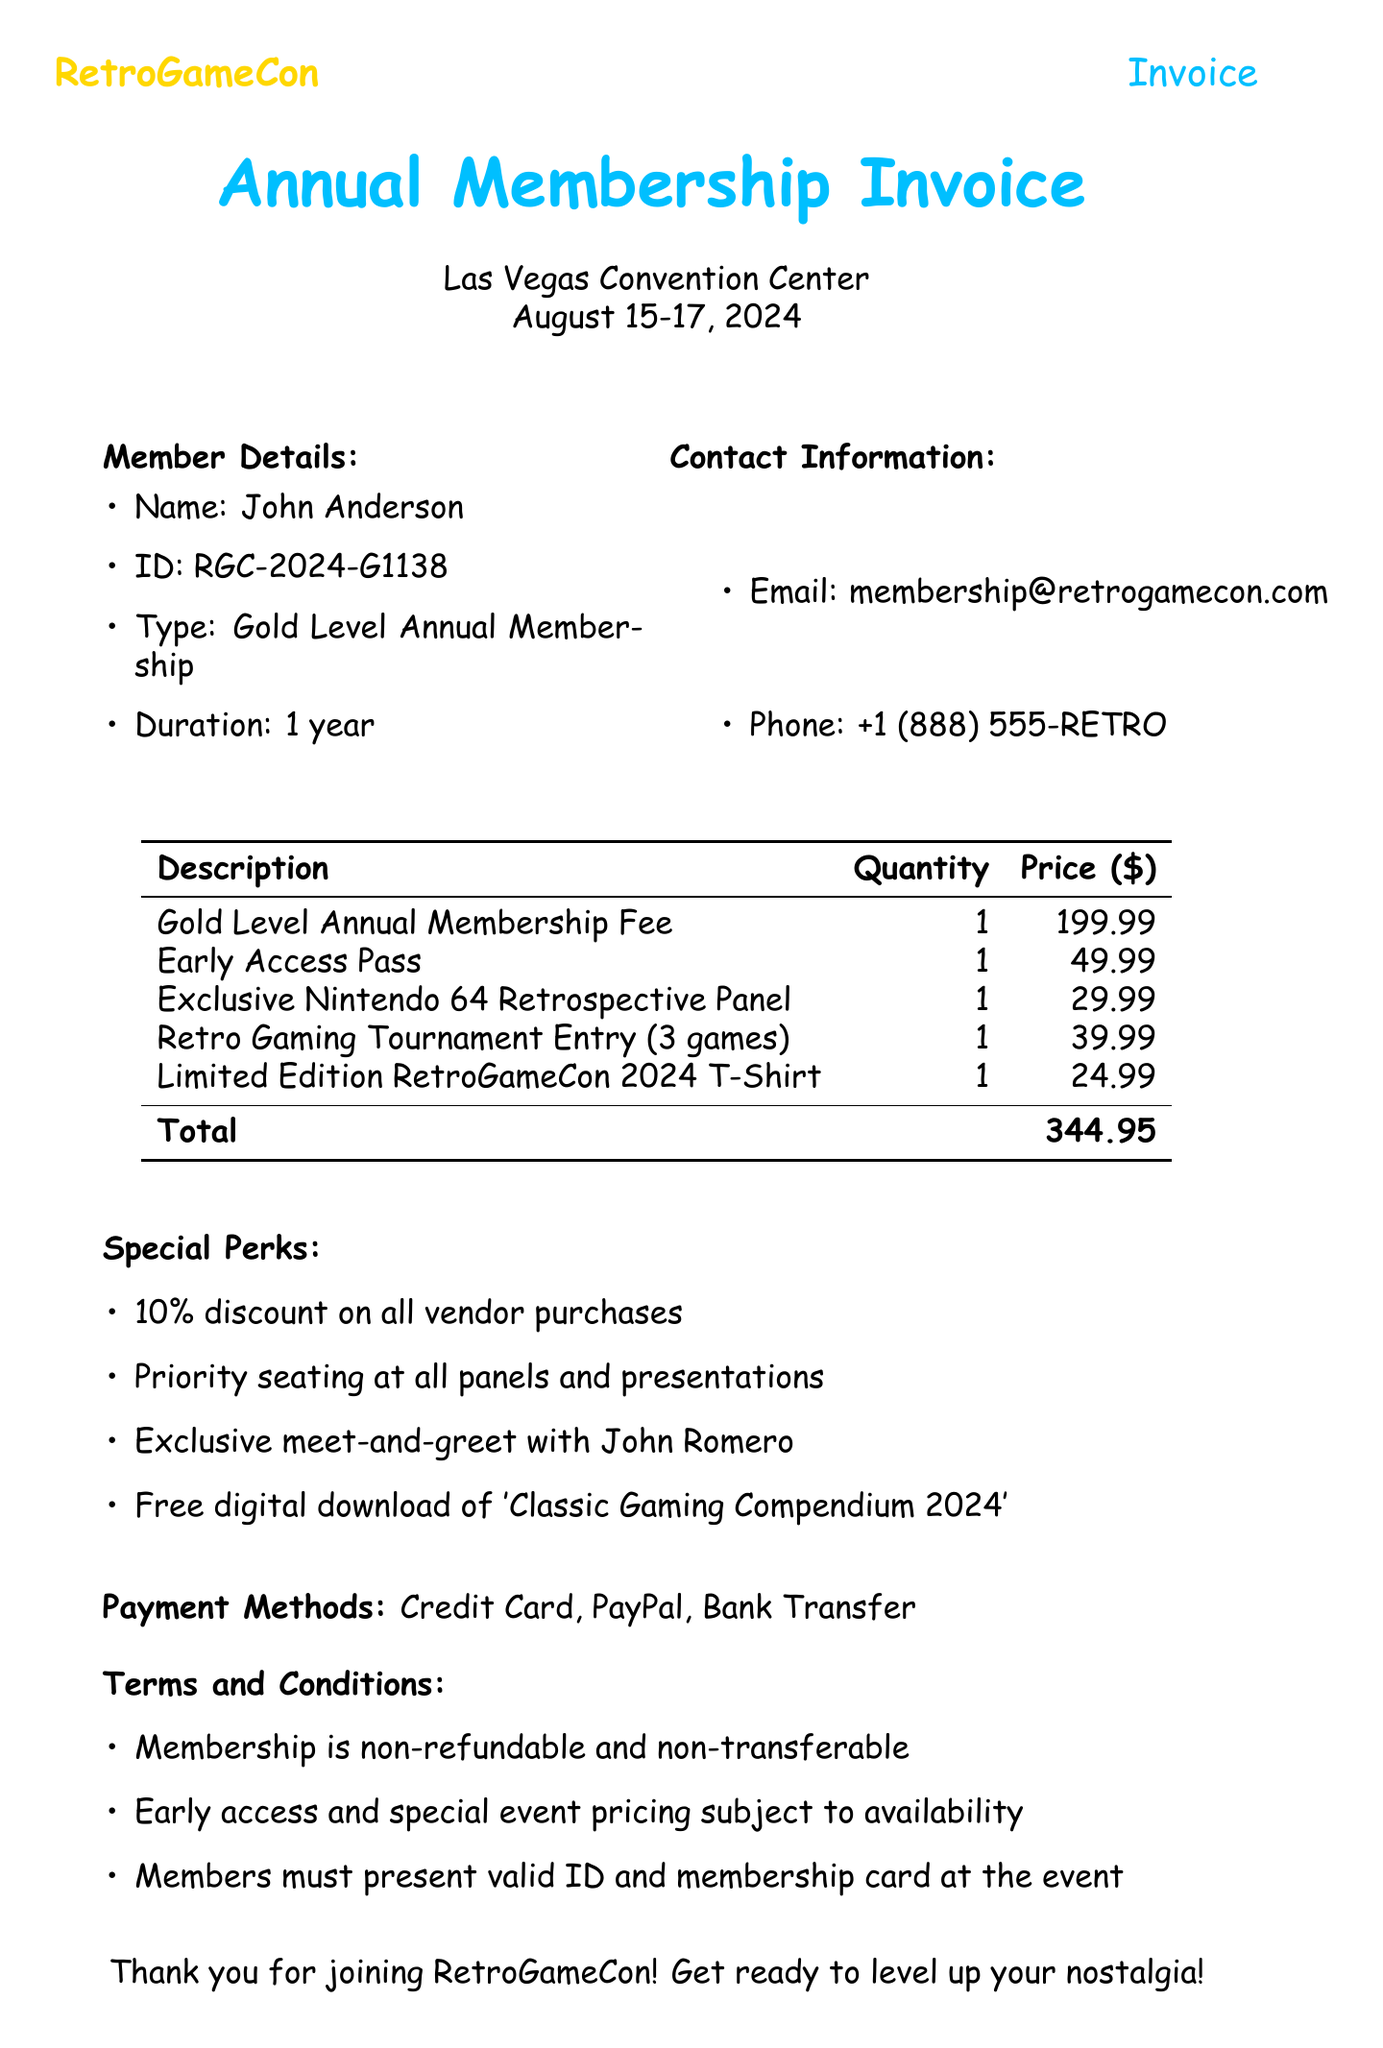What is the event date? The event date is specified in the invoice and falls between August 15-17, 2024.
Answer: August 15-17, 2024 Who is the member? The member's name is mentioned in the document, specifically as John Anderson.
Answer: John Anderson What is the total amount due? The total amount is calculated by summing up the costs of all items in the invoice, which is 199.99 + 49.99 + 29.99 + 39.99 + 24.99.
Answer: 344.95 What type of membership is this? The membership type is stated in the document as Gold Level Annual Membership.
Answer: Gold Level Annual Membership What is one of the payment methods? The document lists various payment methods, one of which is Credit Card.
Answer: Credit Card How long is the membership duration? The membership duration is explicitly given as 1 year in the invoice.
Answer: 1 year What discount is offered to members? The invoice specifies a 10% discount on all vendor purchases as one of the perks.
Answer: 10% Is membership refundable? The terms clearly state that membership is non-refundable.
Answer: Non-refundable What exclusive event is included? The invoice includes access to the Exclusive Nintendo 64 Retrospective Panel.
Answer: Exclusive Nintendo 64 Retrospective Panel 